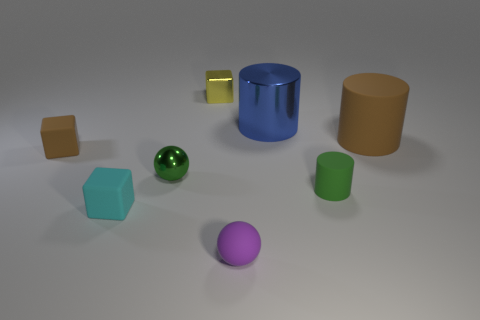There is a tiny cyan thing that is the same material as the purple sphere; what shape is it?
Offer a terse response. Cube. What is the color of the big cylinder that is behind the large thing that is to the right of the large blue thing?
Offer a terse response. Blue. Do the large matte cylinder and the small rubber sphere have the same color?
Provide a short and direct response. No. What material is the tiny green thing that is in front of the tiny shiny thing in front of the large rubber cylinder?
Give a very brief answer. Rubber. What material is the green object that is the same shape as the tiny purple matte object?
Your answer should be very brief. Metal. Is there a tiny brown rubber thing that is in front of the tiny object that is behind the matte block that is on the left side of the small cyan thing?
Provide a short and direct response. Yes. How many other objects are the same color as the small metallic cube?
Give a very brief answer. 0. How many matte things are to the left of the tiny cyan matte object and behind the small brown cube?
Make the answer very short. 0. The big metal thing is what shape?
Your answer should be very brief. Cylinder. How many other things are there of the same material as the small brown block?
Give a very brief answer. 4. 